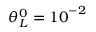<formula> <loc_0><loc_0><loc_500><loc_500>\theta _ { L } ^ { 0 } = { { 1 0 } ^ { - 2 } }</formula> 